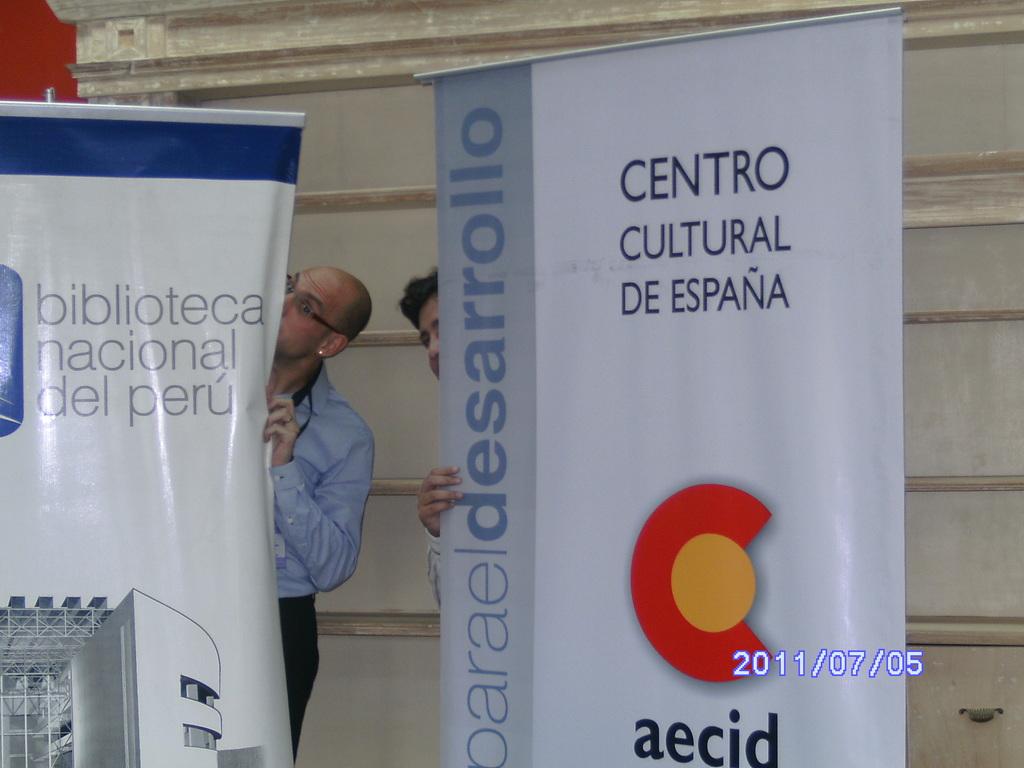When was this photo taken?
Provide a short and direct response. 2011/07/05. 